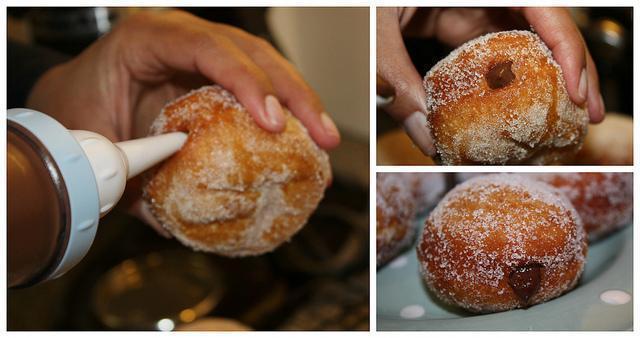What does the container hold?
From the following four choices, select the correct answer to address the question.
Options: Jelly, cream, sugar, butter. Jelly. 